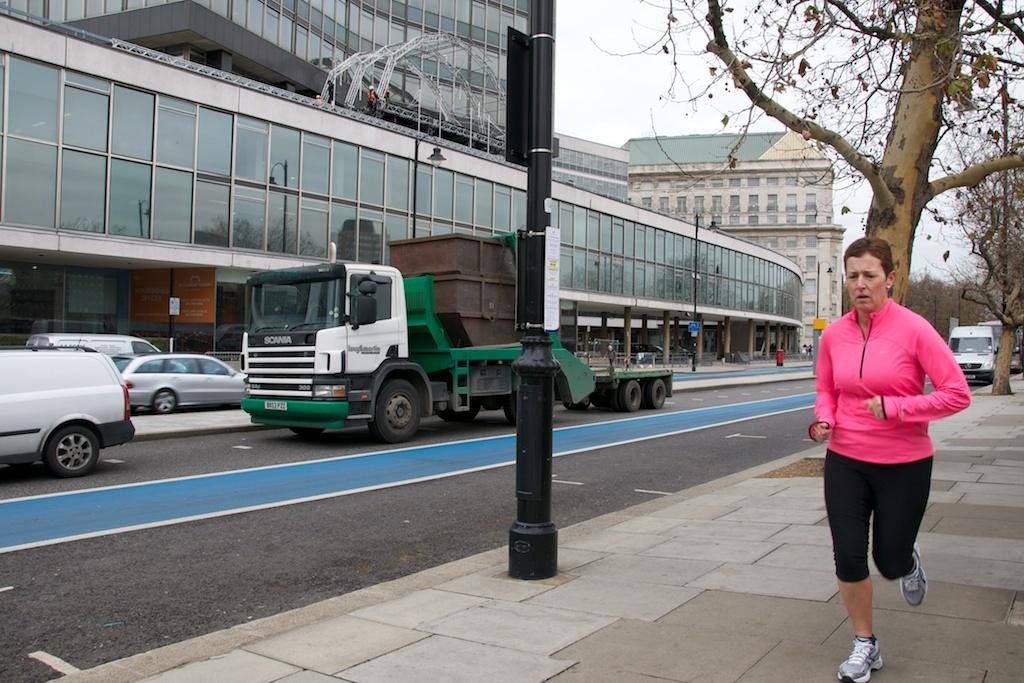What is the woman in the image doing? The woman is running in the image. Where is the woman running? The woman is running on a footpath. What else can be seen in the image besides the woman? There are vehicles on the road, trees, buildings, poles, and the sky visible in the background. What type of land can be seen growing from the roots of the trees in the image? There are no roots or land visible in the image; it only shows trees, not their roots or the type of land they might be growing from. 